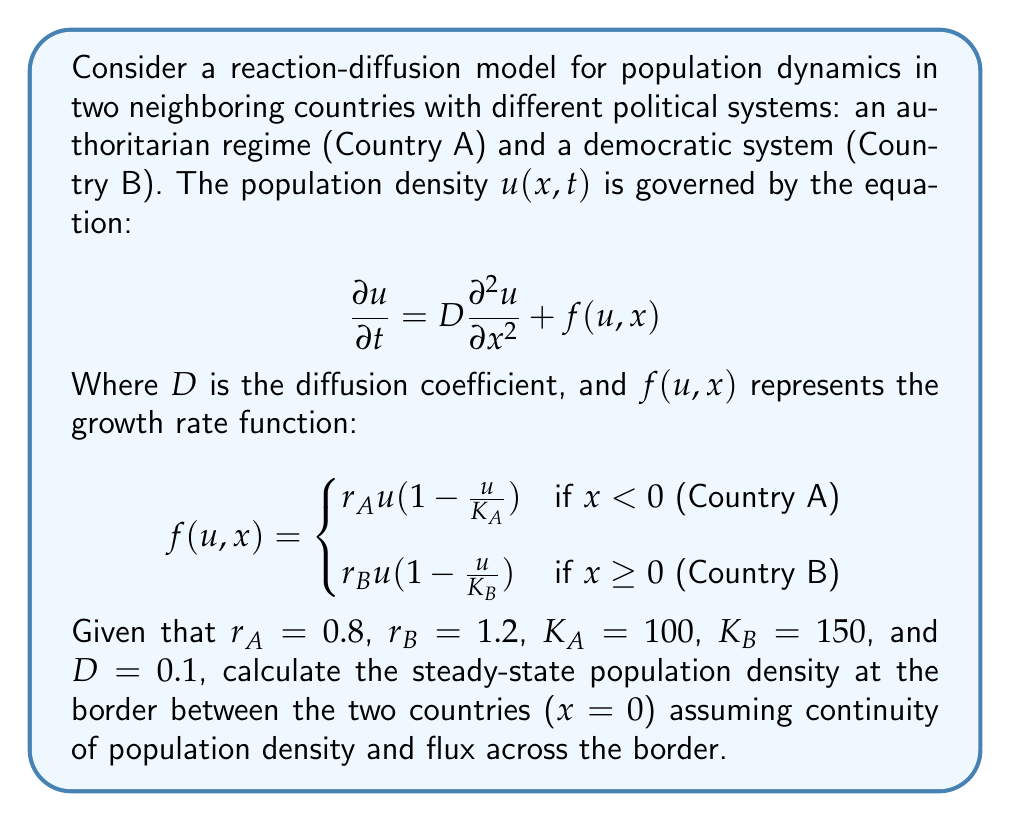Give your solution to this math problem. To solve this problem, we need to follow these steps:

1) At steady state, $\frac{\partial u}{\partial t} = 0$, so our equation becomes:

   $$0 = D\frac{\partial^2 u}{\partial x^2} + f(u,x)$$

2) At the border ($x = 0$), we need to ensure continuity of population density and flux. Let's call the steady-state population density at the border $u_0$.

3) For continuity of population density:
   $u_A(0) = u_B(0) = u_0$

4) For continuity of flux:
   $$D\frac{\partial u_A}{\partial x}(0) = D\frac{\partial u_B}{\partial x}(0)$$

5) At steady state in Country A ($x < 0$):
   $$0 = D\frac{\partial^2 u_A}{\partial x^2} + r_A u_A(1-\frac{u_A}{K_A})$$

6) At steady state in Country B ($x \geq 0$):
   $$0 = D\frac{\partial^2 u_B}{\partial x^2} + r_B u_B(1-\frac{u_B}{K_B})$$

7) At the border, these equations should be equal:
   $$r_A u_0(1-\frac{u_0}{K_A}) = r_B u_0(1-\frac{u_0}{K_B})$$

8) Simplifying:
   $$0.8 u_0(1-\frac{u_0}{100}) = 1.2 u_0(1-\frac{u_0}{150})$$

9) Expanding:
   $$0.8u_0 - 0.008u_0^2 = 1.2u_0 - 0.008u_0^2$$

10) Solving for $u_0$:
    $$-0.4u_0 = 0$$
    $$u_0 = 0$$

11) However, $u_0 = 0$ is a trivial solution. The non-trivial solution can be found by dividing both sides by $u_0$:

    $$0.8 - 0.008u_0 = 1.2 - 0.008u_0$$
    $$0.8 = 1.2$$

This equation has no solution, indicating that there is no non-zero steady-state population density at the border that satisfies both continuity conditions.
Answer: No non-zero steady-state solution exists at the border. 